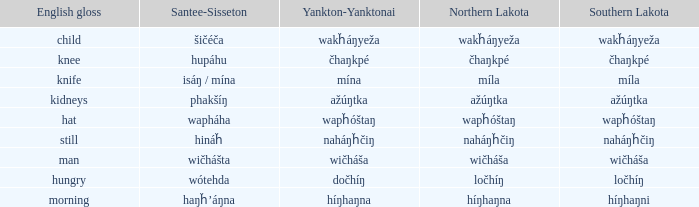Identify the santee sisseton expression for "wičháša." Wičhášta. 